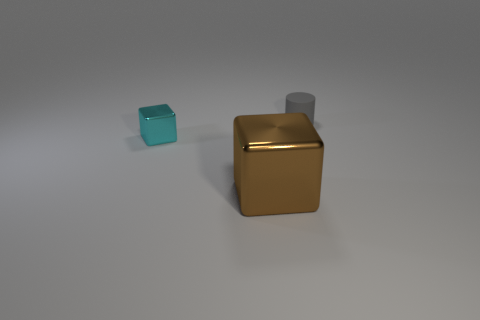Add 1 large brown cubes. How many objects exist? 4 Subtract all blocks. How many objects are left? 1 Subtract 0 yellow spheres. How many objects are left? 3 Subtract all blue spheres. Subtract all tiny cyan things. How many objects are left? 2 Add 2 gray cylinders. How many gray cylinders are left? 3 Add 1 brown objects. How many brown objects exist? 2 